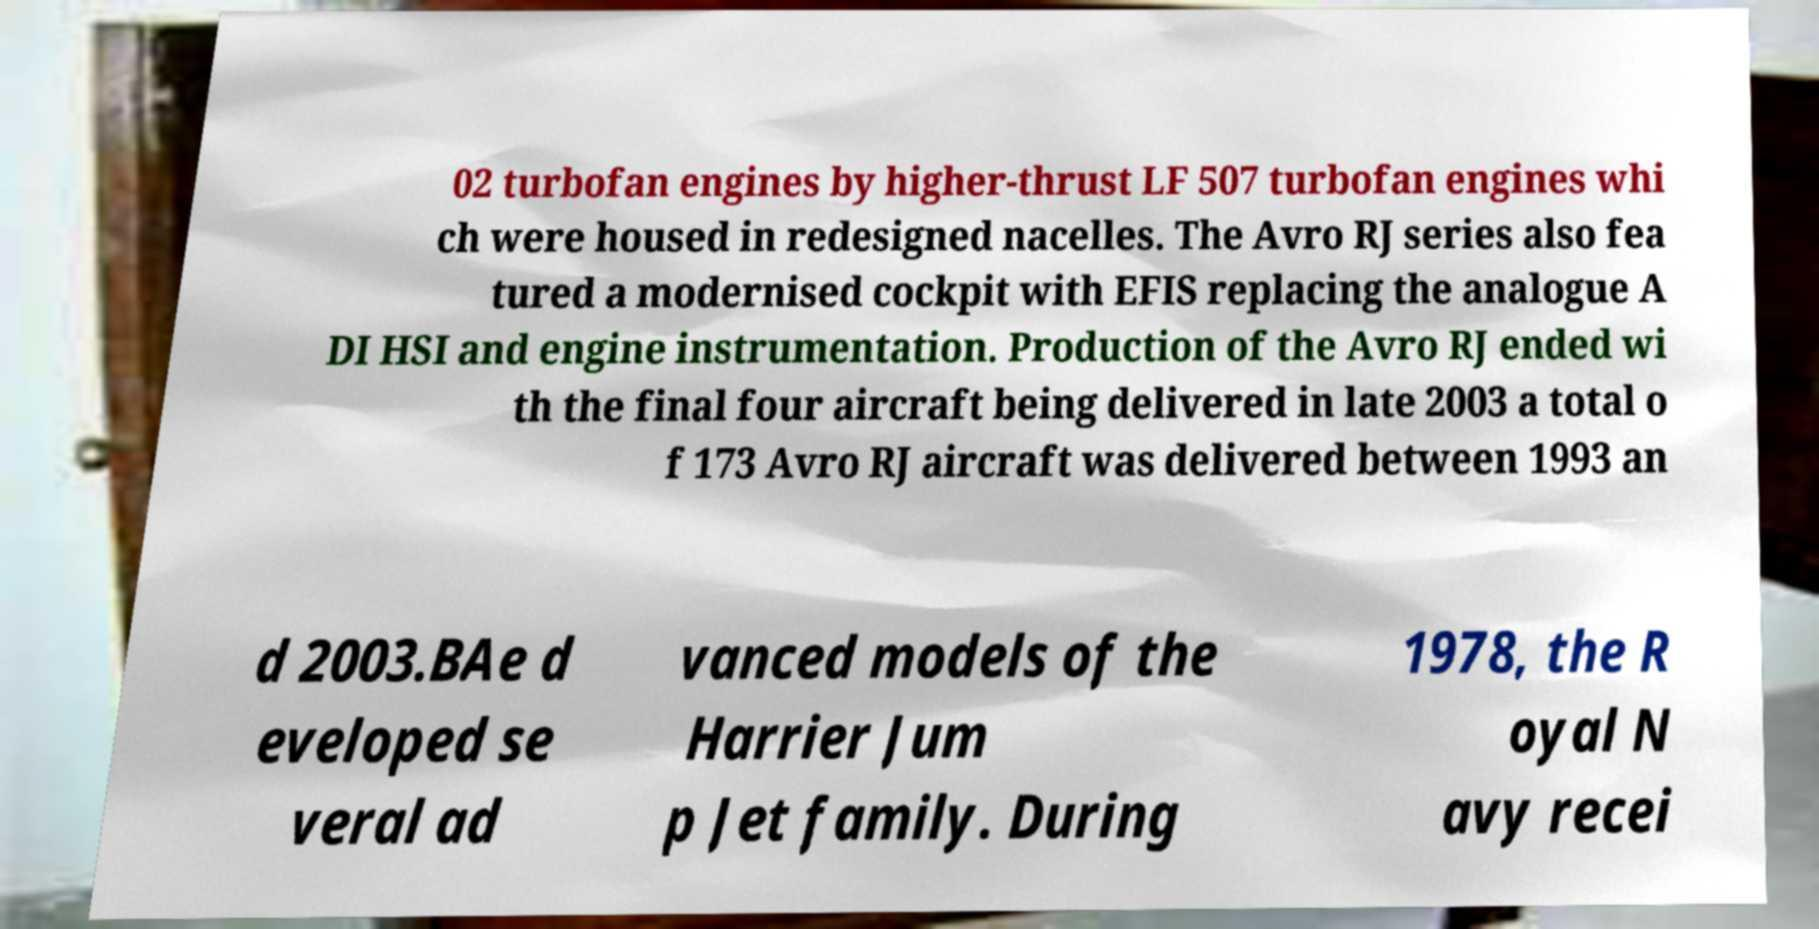Could you assist in decoding the text presented in this image and type it out clearly? 02 turbofan engines by higher-thrust LF 507 turbofan engines whi ch were housed in redesigned nacelles. The Avro RJ series also fea tured a modernised cockpit with EFIS replacing the analogue A DI HSI and engine instrumentation. Production of the Avro RJ ended wi th the final four aircraft being delivered in late 2003 a total o f 173 Avro RJ aircraft was delivered between 1993 an d 2003.BAe d eveloped se veral ad vanced models of the Harrier Jum p Jet family. During 1978, the R oyal N avy recei 